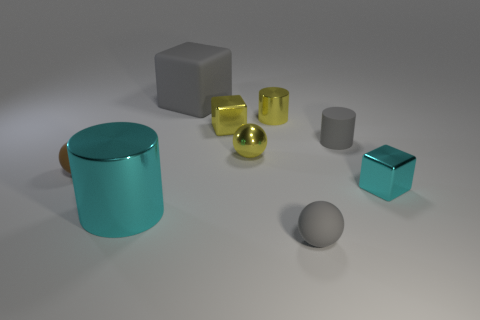How many things are small red rubber blocks or objects?
Keep it short and to the point. 9. The rubber block is what color?
Your answer should be very brief. Gray. How many other objects are the same color as the matte cube?
Your response must be concise. 2. There is a large metal cylinder; are there any brown matte spheres left of it?
Provide a succinct answer. Yes. What is the color of the tiny matte thing in front of the cyan object that is on the right side of the yellow object that is in front of the matte cylinder?
Ensure brevity in your answer.  Gray. What number of objects are right of the large cyan metallic object and in front of the gray cylinder?
Your answer should be very brief. 3. How many spheres are purple rubber things or small shiny things?
Provide a succinct answer. 1. Are any large yellow rubber cylinders visible?
Keep it short and to the point. No. How many other things are made of the same material as the small yellow cube?
Provide a succinct answer. 4. There is a brown sphere that is the same size as the yellow metallic sphere; what material is it?
Offer a very short reply. Rubber. 